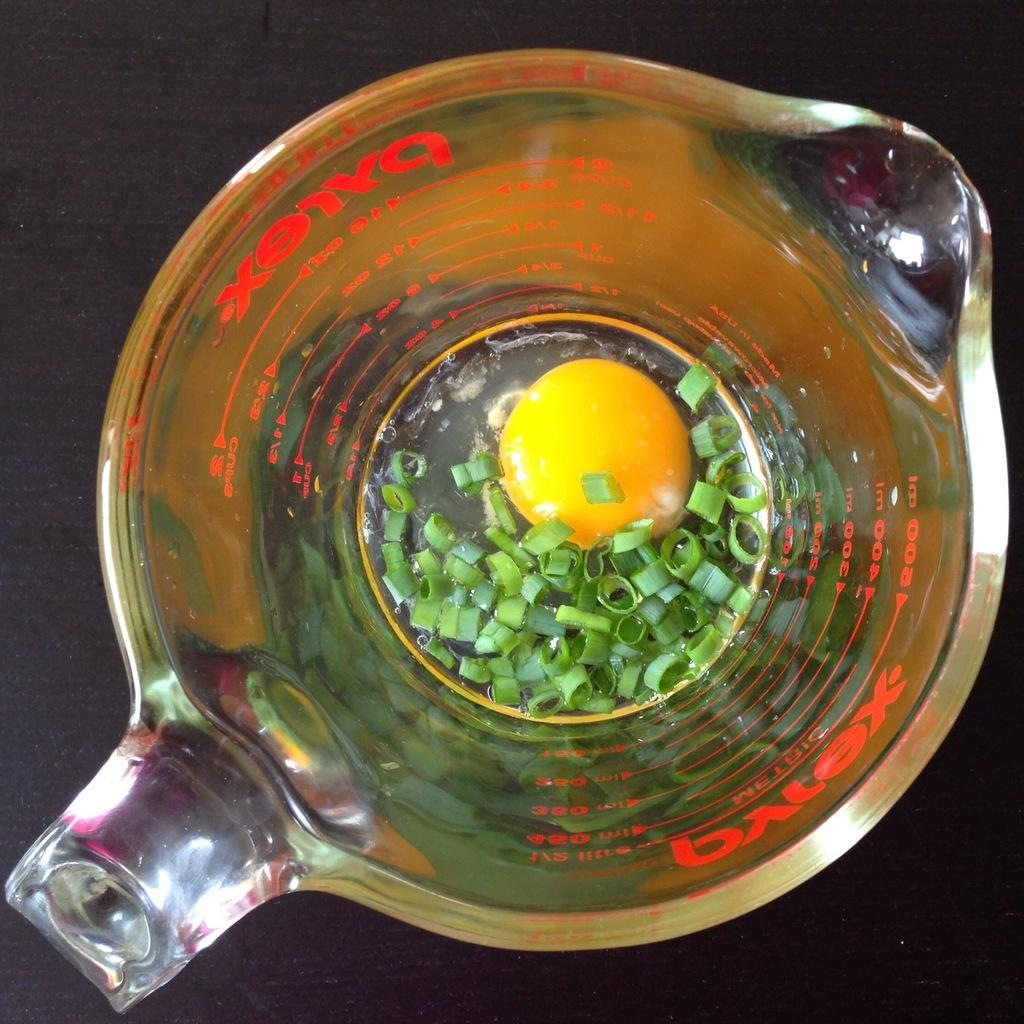What piece of furniture is present in the image? There is a table in the image. What object is placed on the table? There is a glass on the table. What is inside the glass? There is an egg inside the glass, along with slices of spring onions. How does the event increase the number of participants in the image? There is no event present in the image, and therefore no increase in participants can be observed. 